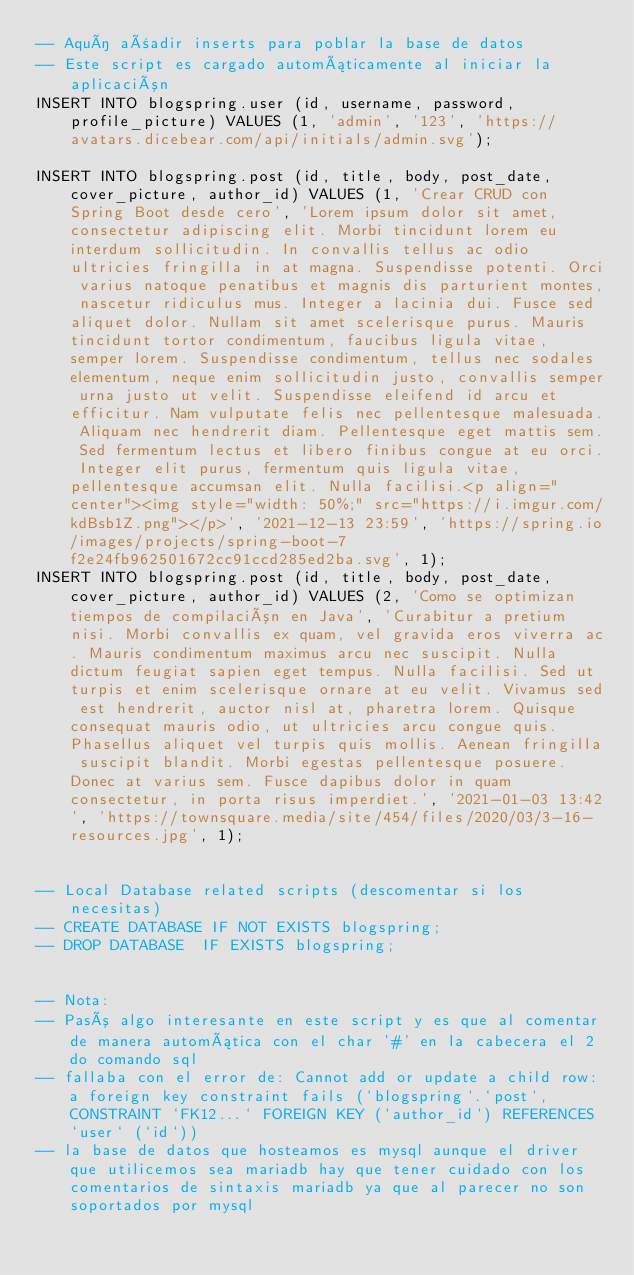Convert code to text. <code><loc_0><loc_0><loc_500><loc_500><_SQL_>-- Aquí añadir inserts para poblar la base de datos
-- Este script es cargado automáticamente al iniciar la aplicación
INSERT INTO blogspring.user (id, username, password, profile_picture) VALUES (1, 'admin', '123', 'https://avatars.dicebear.com/api/initials/admin.svg');

INSERT INTO blogspring.post (id, title, body, post_date, cover_picture, author_id) VALUES (1, 'Crear CRUD con Spring Boot desde cero', 'Lorem ipsum dolor sit amet, consectetur adipiscing elit. Morbi tincidunt lorem eu interdum sollicitudin. In convallis tellus ac odio ultricies fringilla in at magna. Suspendisse potenti. Orci varius natoque penatibus et magnis dis parturient montes, nascetur ridiculus mus. Integer a lacinia dui. Fusce sed aliquet dolor. Nullam sit amet scelerisque purus. Mauris tincidunt tortor condimentum, faucibus ligula vitae, semper lorem. Suspendisse condimentum, tellus nec sodales elementum, neque enim sollicitudin justo, convallis semper urna justo ut velit. Suspendisse eleifend id arcu et efficitur. Nam vulputate felis nec pellentesque malesuada. Aliquam nec hendrerit diam. Pellentesque eget mattis sem. Sed fermentum lectus et libero finibus congue at eu orci. Integer elit purus, fermentum quis ligula vitae, pellentesque accumsan elit. Nulla facilisi.<p align="center"><img style="width: 50%;" src="https://i.imgur.com/kdBsb1Z.png"></p>', '2021-12-13 23:59', 'https://spring.io/images/projects/spring-boot-7f2e24fb962501672cc91ccd285ed2ba.svg', 1);
INSERT INTO blogspring.post (id, title, body, post_date, cover_picture, author_id) VALUES (2, 'Como se optimizan tiempos de compilación en Java', 'Curabitur a pretium nisi. Morbi convallis ex quam, vel gravida eros viverra ac. Mauris condimentum maximus arcu nec suscipit. Nulla dictum feugiat sapien eget tempus. Nulla facilisi. Sed ut turpis et enim scelerisque ornare at eu velit. Vivamus sed est hendrerit, auctor nisl at, pharetra lorem. Quisque consequat mauris odio, ut ultricies arcu congue quis. Phasellus aliquet vel turpis quis mollis. Aenean fringilla suscipit blandit. Morbi egestas pellentesque posuere. Donec at varius sem. Fusce dapibus dolor in quam consectetur, in porta risus imperdiet.', '2021-01-03 13:42', 'https://townsquare.media/site/454/files/2020/03/3-16-resources.jpg', 1);


-- Local Database related scripts (descomentar si los necesitas)
-- CREATE DATABASE IF NOT EXISTS blogspring;
-- DROP DATABASE  IF EXISTS blogspring;


-- Nota:
-- Pasó algo interesante en este script y es que al comentar de manera automática con el char '#' en la cabecera el 2do comando sql
-- fallaba con el error de: Cannot add or update a child row: a foreign key constraint fails (`blogspring`.`post`, CONSTRAINT `FK12...` FOREIGN KEY (`author_id`) REFERENCES `user` (`id`))
-- la base de datos que hosteamos es mysql aunque el driver que utilicemos sea mariadb hay que tener cuidado con los comentarios de sintaxis mariadb ya que al parecer no son soportados por mysql</code> 